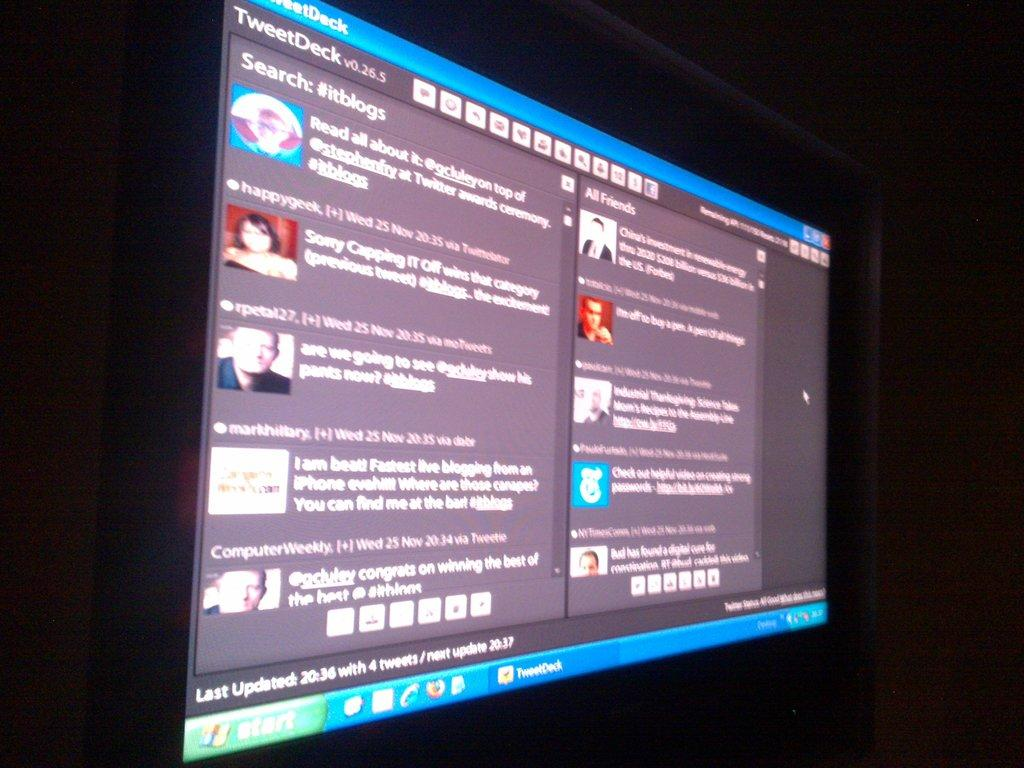<image>
Present a compact description of the photo's key features. A large video board of Tweet Deck which was last updated at 20:36. 